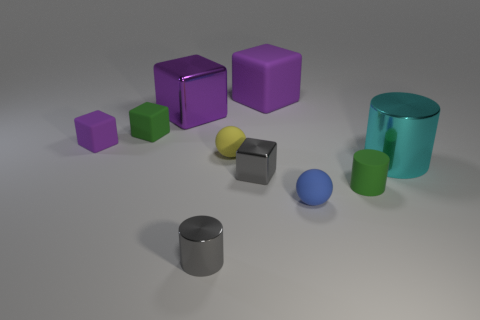Subtract all rubber cylinders. How many cylinders are left? 2 Subtract all gray cylinders. How many cylinders are left? 2 Subtract 3 cubes. How many cubes are left? 2 Subtract all purple blocks. How many brown spheres are left? 0 Add 4 tiny purple rubber things. How many tiny purple rubber things exist? 5 Subtract 0 cyan spheres. How many objects are left? 10 Subtract all spheres. How many objects are left? 8 Subtract all yellow balls. Subtract all yellow cubes. How many balls are left? 1 Subtract all small gray cylinders. Subtract all cyan metal cylinders. How many objects are left? 8 Add 6 rubber blocks. How many rubber blocks are left? 9 